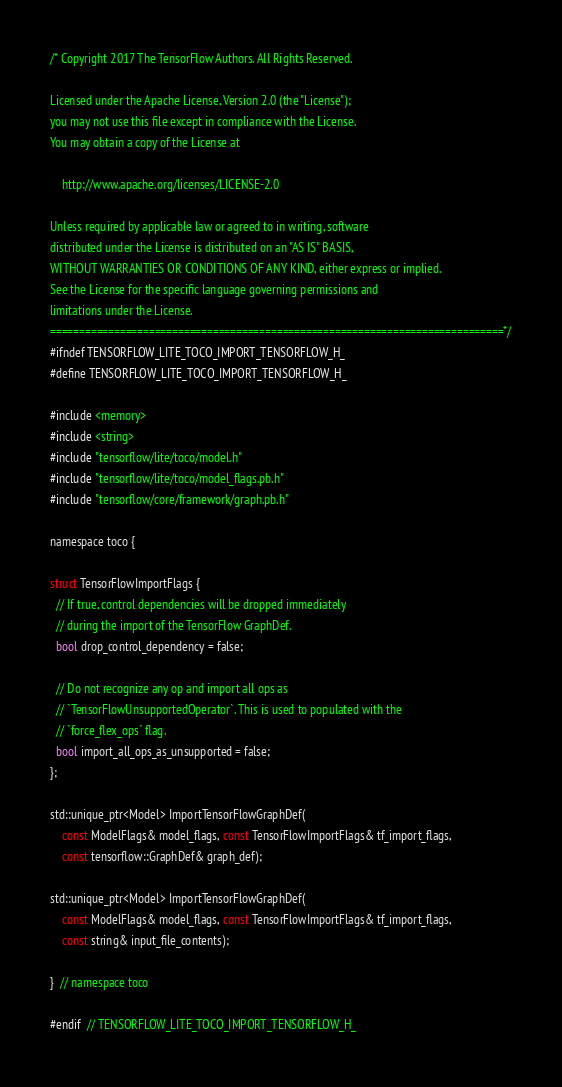<code> <loc_0><loc_0><loc_500><loc_500><_C_>/* Copyright 2017 The TensorFlow Authors. All Rights Reserved.

Licensed under the Apache License, Version 2.0 (the "License");
you may not use this file except in compliance with the License.
You may obtain a copy of the License at

    http://www.apache.org/licenses/LICENSE-2.0

Unless required by applicable law or agreed to in writing, software
distributed under the License is distributed on an "AS IS" BASIS,
WITHOUT WARRANTIES OR CONDITIONS OF ANY KIND, either express or implied.
See the License for the specific language governing permissions and
limitations under the License.
==============================================================================*/
#ifndef TENSORFLOW_LITE_TOCO_IMPORT_TENSORFLOW_H_
#define TENSORFLOW_LITE_TOCO_IMPORT_TENSORFLOW_H_

#include <memory>
#include <string>
#include "tensorflow/lite/toco/model.h"
#include "tensorflow/lite/toco/model_flags.pb.h"
#include "tensorflow/core/framework/graph.pb.h"

namespace toco {

struct TensorFlowImportFlags {
  // If true, control dependencies will be dropped immediately
  // during the import of the TensorFlow GraphDef.
  bool drop_control_dependency = false;

  // Do not recognize any op and import all ops as
  // `TensorFlowUnsupportedOperator`. This is used to populated with the
  // `force_flex_ops` flag.
  bool import_all_ops_as_unsupported = false;
};

std::unique_ptr<Model> ImportTensorFlowGraphDef(
    const ModelFlags& model_flags, const TensorFlowImportFlags& tf_import_flags,
    const tensorflow::GraphDef& graph_def);

std::unique_ptr<Model> ImportTensorFlowGraphDef(
    const ModelFlags& model_flags, const TensorFlowImportFlags& tf_import_flags,
    const string& input_file_contents);

}  // namespace toco

#endif  // TENSORFLOW_LITE_TOCO_IMPORT_TENSORFLOW_H_
</code> 